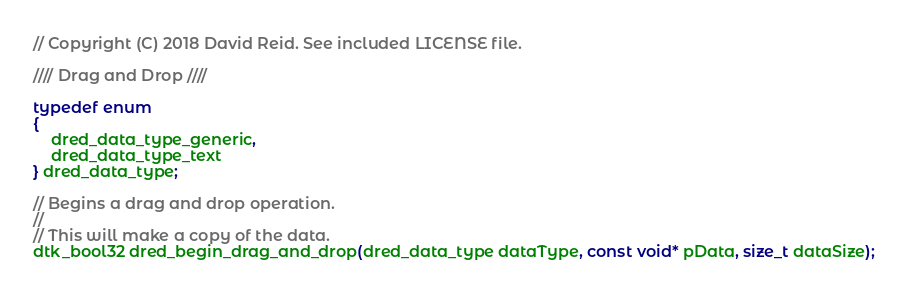Convert code to text. <code><loc_0><loc_0><loc_500><loc_500><_C_>// Copyright (C) 2018 David Reid. See included LICENSE file.

//// Drag and Drop ////

typedef enum
{
    dred_data_type_generic,
    dred_data_type_text
} dred_data_type;

// Begins a drag and drop operation.
//
// This will make a copy of the data.
dtk_bool32 dred_begin_drag_and_drop(dred_data_type dataType, const void* pData, size_t dataSize);
</code> 